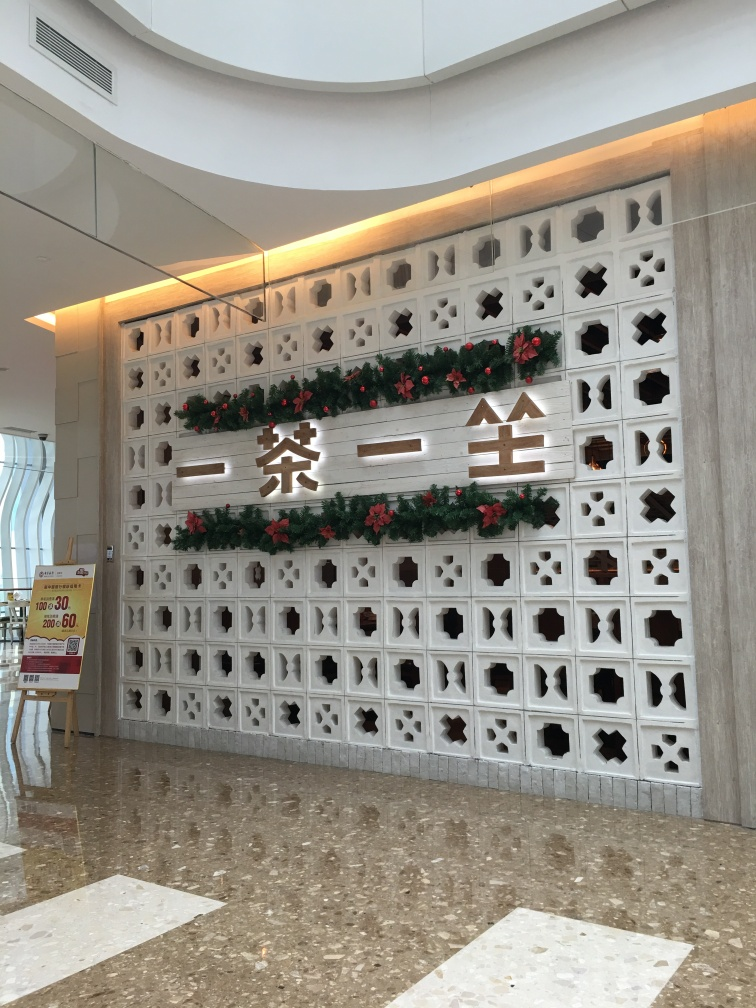What cultural elements can be observed in this architectural space? The architectural space depicted in the image presents a blend of modern and traditional elements. The Chinese characters prominently displayed suggest a cultural link, likely indicating the location or the theme of the space. The traditional geometric patterns within the wall panels further emphasize cultural roots, while decorated with contemporary Christmas adornments, showcasing a fusion of Western and Eastern cultures. 